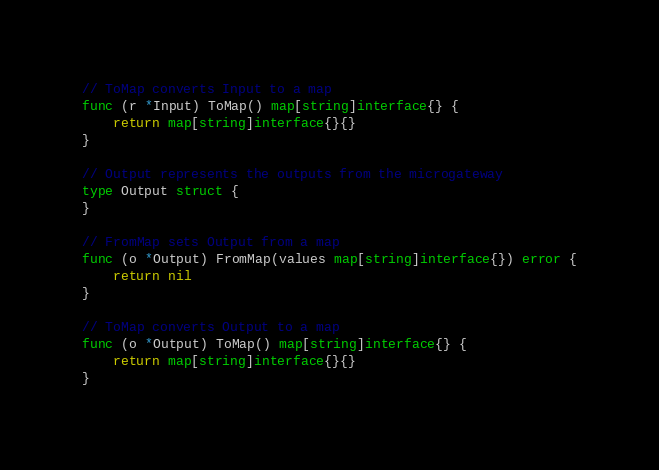Convert code to text. <code><loc_0><loc_0><loc_500><loc_500><_Go_>// ToMap converts Input to a map
func (r *Input) ToMap() map[string]interface{} {
	return map[string]interface{}{}
}

// Output represents the outputs from the microgateway
type Output struct {
}

// FromMap sets Output from a map
func (o *Output) FromMap(values map[string]interface{}) error {
	return nil
}

// ToMap converts Output to a map
func (o *Output) ToMap() map[string]interface{} {
	return map[string]interface{}{}
}
</code> 